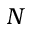<formula> <loc_0><loc_0><loc_500><loc_500>N</formula> 